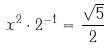<formula> <loc_0><loc_0><loc_500><loc_500>x ^ { 2 } \cdot 2 ^ { - 1 } = \frac { \sqrt { 5 } } { 2 }</formula> 